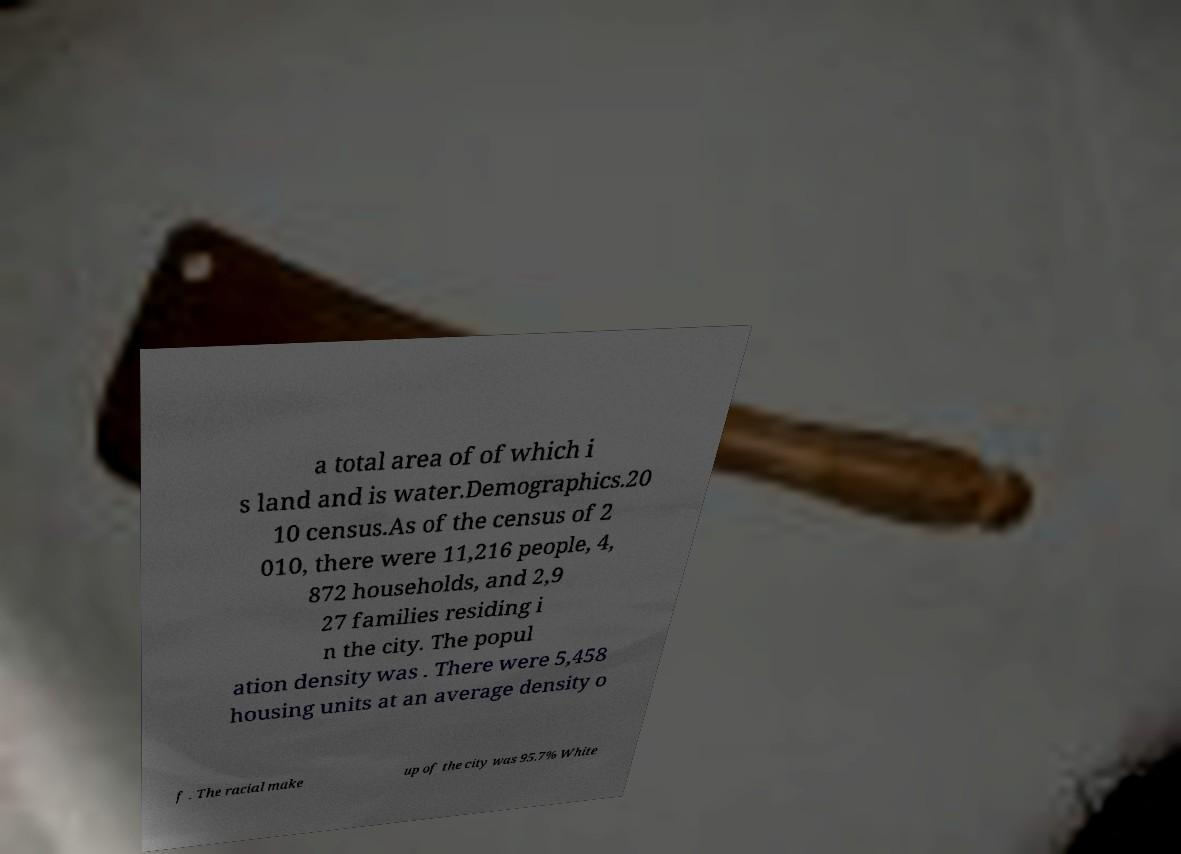Can you accurately transcribe the text from the provided image for me? a total area of of which i s land and is water.Demographics.20 10 census.As of the census of 2 010, there were 11,216 people, 4, 872 households, and 2,9 27 families residing i n the city. The popul ation density was . There were 5,458 housing units at an average density o f . The racial make up of the city was 95.7% White 